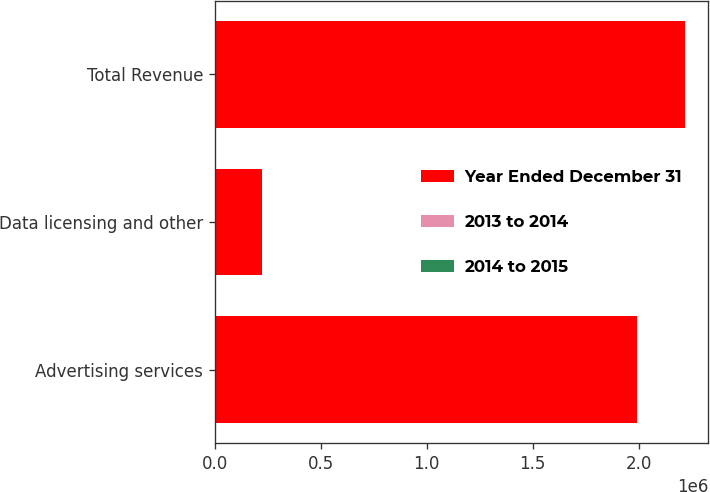Convert chart to OTSL. <chart><loc_0><loc_0><loc_500><loc_500><stacked_bar_chart><ecel><fcel>Advertising services<fcel>Data licensing and other<fcel>Total Revenue<nl><fcel>Year Ended December 31<fcel>1.99404e+06<fcel>223996<fcel>2.21803e+06<nl><fcel>2013 to 2014<fcel>59<fcel>52<fcel>58<nl><fcel>2014 to 2015<fcel>111<fcel>109<fcel>111<nl></chart> 